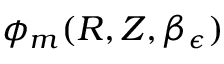<formula> <loc_0><loc_0><loc_500><loc_500>\phi _ { m } ( R , Z , \beta _ { \epsilon } )</formula> 